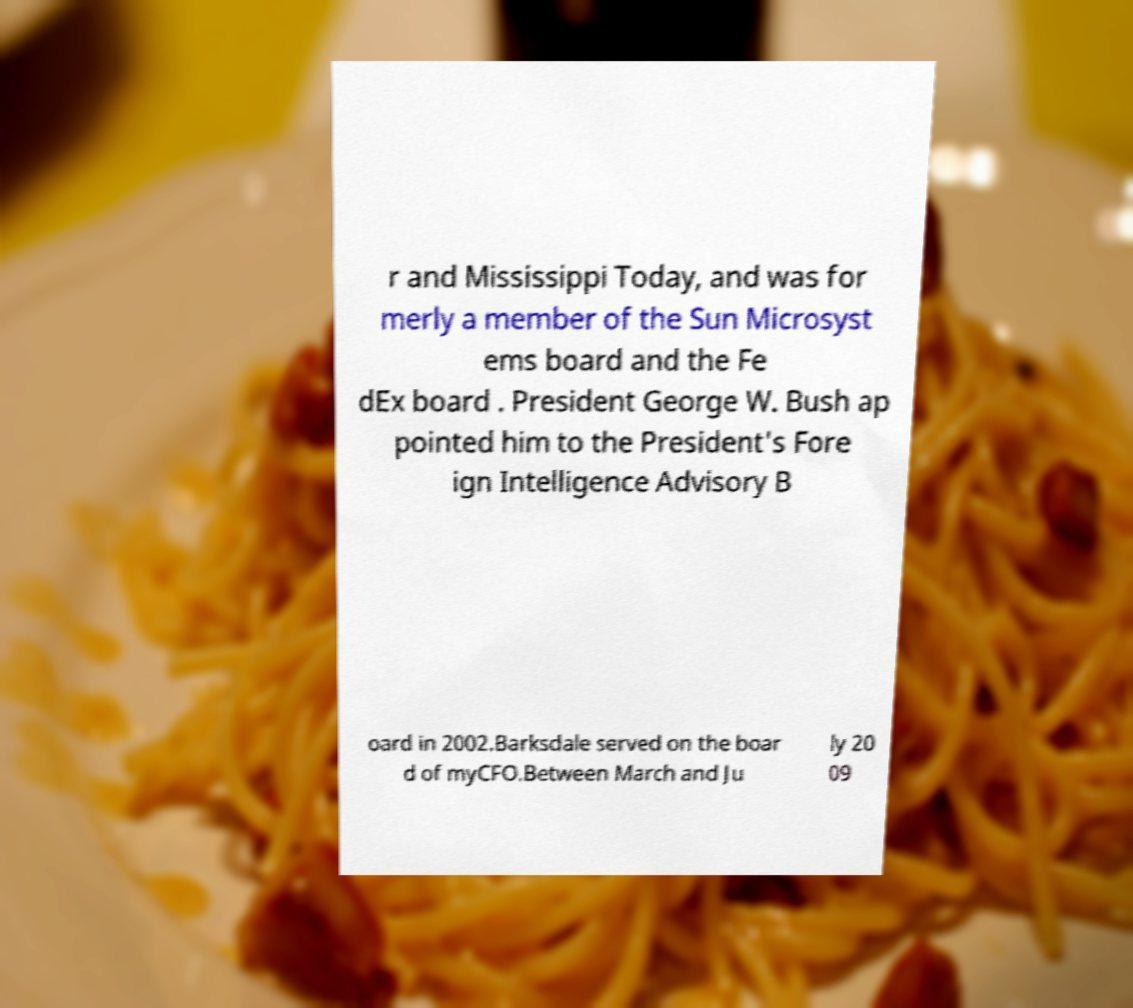There's text embedded in this image that I need extracted. Can you transcribe it verbatim? r and Mississippi Today, and was for merly a member of the Sun Microsyst ems board and the Fe dEx board . President George W. Bush ap pointed him to the President's Fore ign Intelligence Advisory B oard in 2002.Barksdale served on the boar d of myCFO.Between March and Ju ly 20 09 